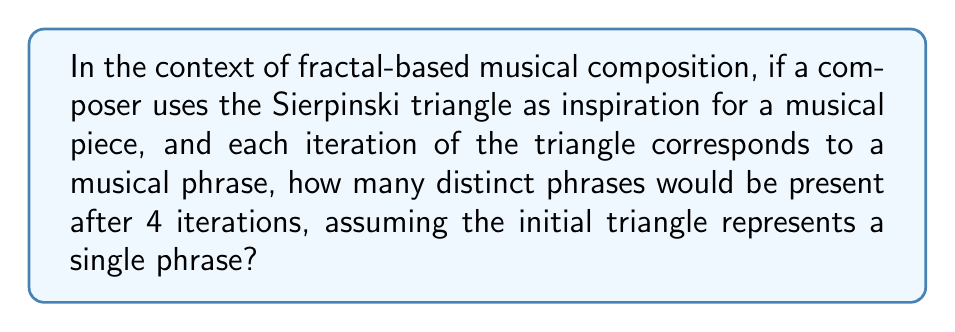Solve this math problem. To solve this problem, we need to understand the structure of the Sierpinski triangle and how it relates to musical composition:

1) The Sierpinski triangle is a fractal that begins with an equilateral triangle and repeatedly creates smaller triangles within it.

2) In each iteration:
   - The number of triangles triples
   - Each new triangle is a smaller copy of the whole

3) Let's count the number of triangles (phrases) for each iteration:
   - Iteration 0 (initial): 1 triangle
   - Iteration 1: $3^1 = 3$ triangles
   - Iteration 2: $3^2 = 9$ triangles
   - Iteration 3: $3^3 = 27$ triangles
   - Iteration 4: $3^4 = 81$ triangles

4) We can express this mathematically as:
   $$ \text{Number of phrases} = 3^n $$
   where $n$ is the number of iterations.

5) For 4 iterations:
   $$ \text{Number of phrases} = 3^4 = 81 $$

Therefore, after 4 iterations, the musical piece inspired by the Sierpinski triangle would contain 81 distinct phrases.
Answer: 81 phrases 